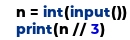<code> <loc_0><loc_0><loc_500><loc_500><_Python_>n = int(input())
print(n // 3)</code> 